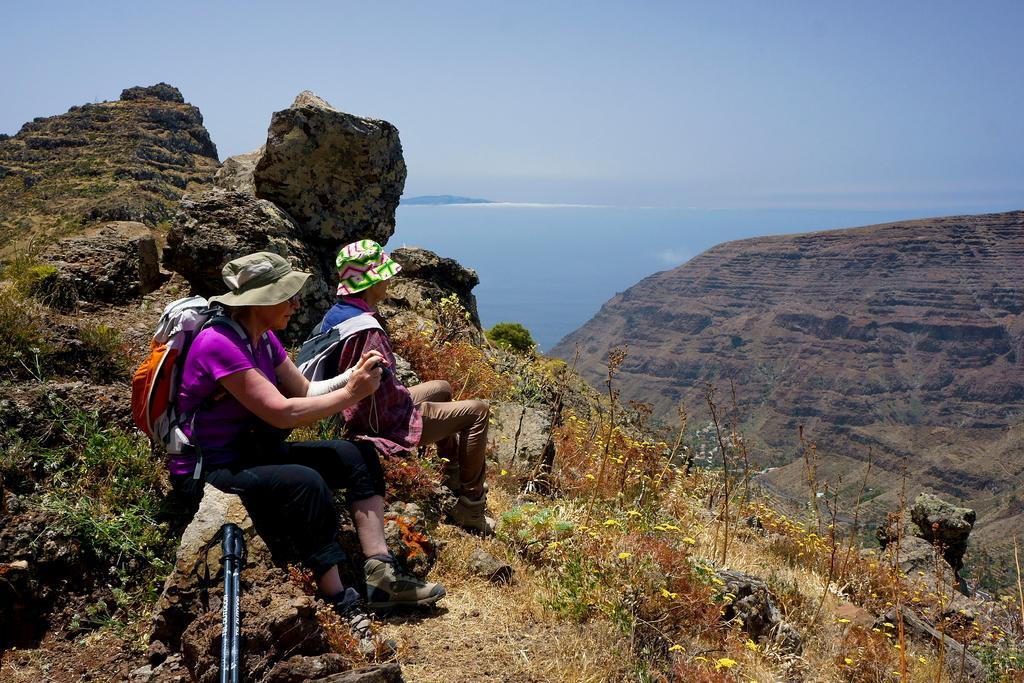Can you describe this image briefly? This picture is taken on a hill. Towards the left, there are two people sitting on the stones. Both of them are wearing hats and carrying bags. At the bottom, there are sticks. On the hill, there are stones and plants. Towards the right, there's another hill. In the background, there is water and sky. 